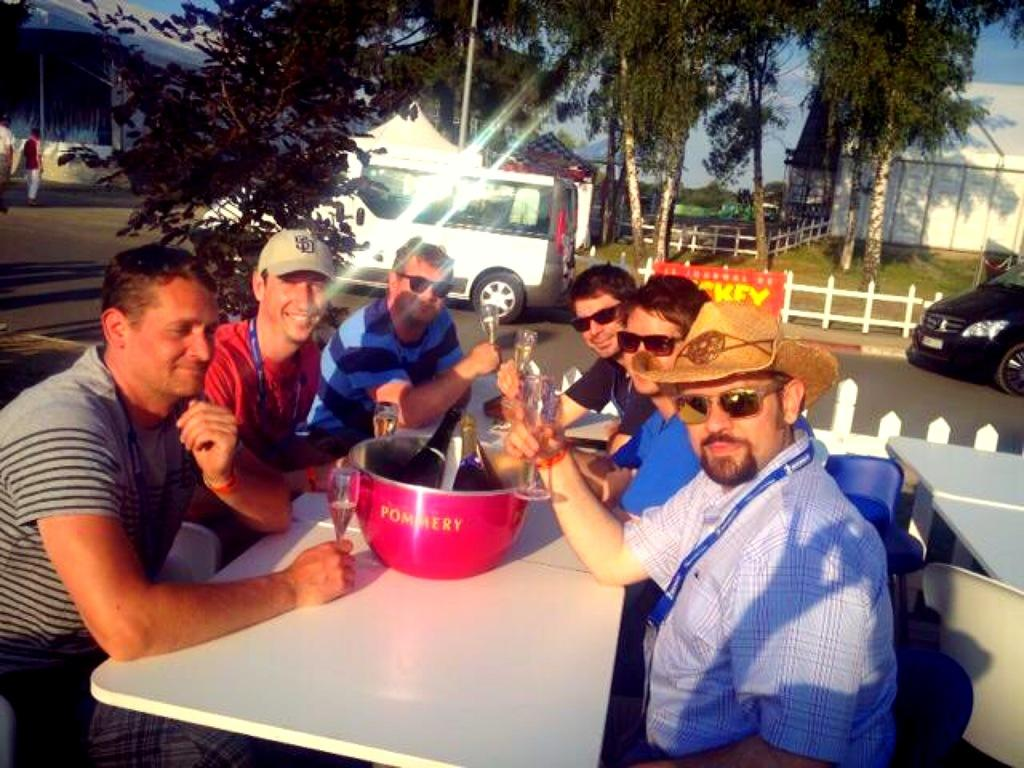What are the people around the table doing? People are sitting around the table and holding glasses. What is on the table with the people? There is a vessel on the table. What is inside the vessel on the table? There are two bottles in the vessel. What can be seen in the background of the image? Cars, a building, trees, and fencing are visible in the background. What caption would best describe the amusement of the beggar in the image? There is no beggar present in the image, so it is not possible to provide a caption for their amusement. 